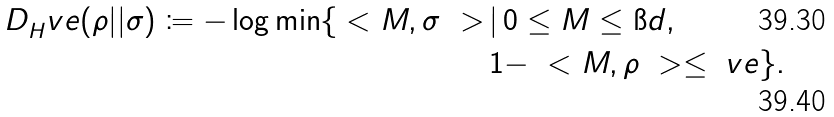<formula> <loc_0><loc_0><loc_500><loc_500>D _ { H } ^ { \ } v e ( \rho | | \sigma ) \coloneqq - \log \min \{ \ < M , \sigma \ > \, & | \, 0 \leq M \leq \i d , \\ & 1 - \ < M , \rho \ > \leq \ v e \} .</formula> 